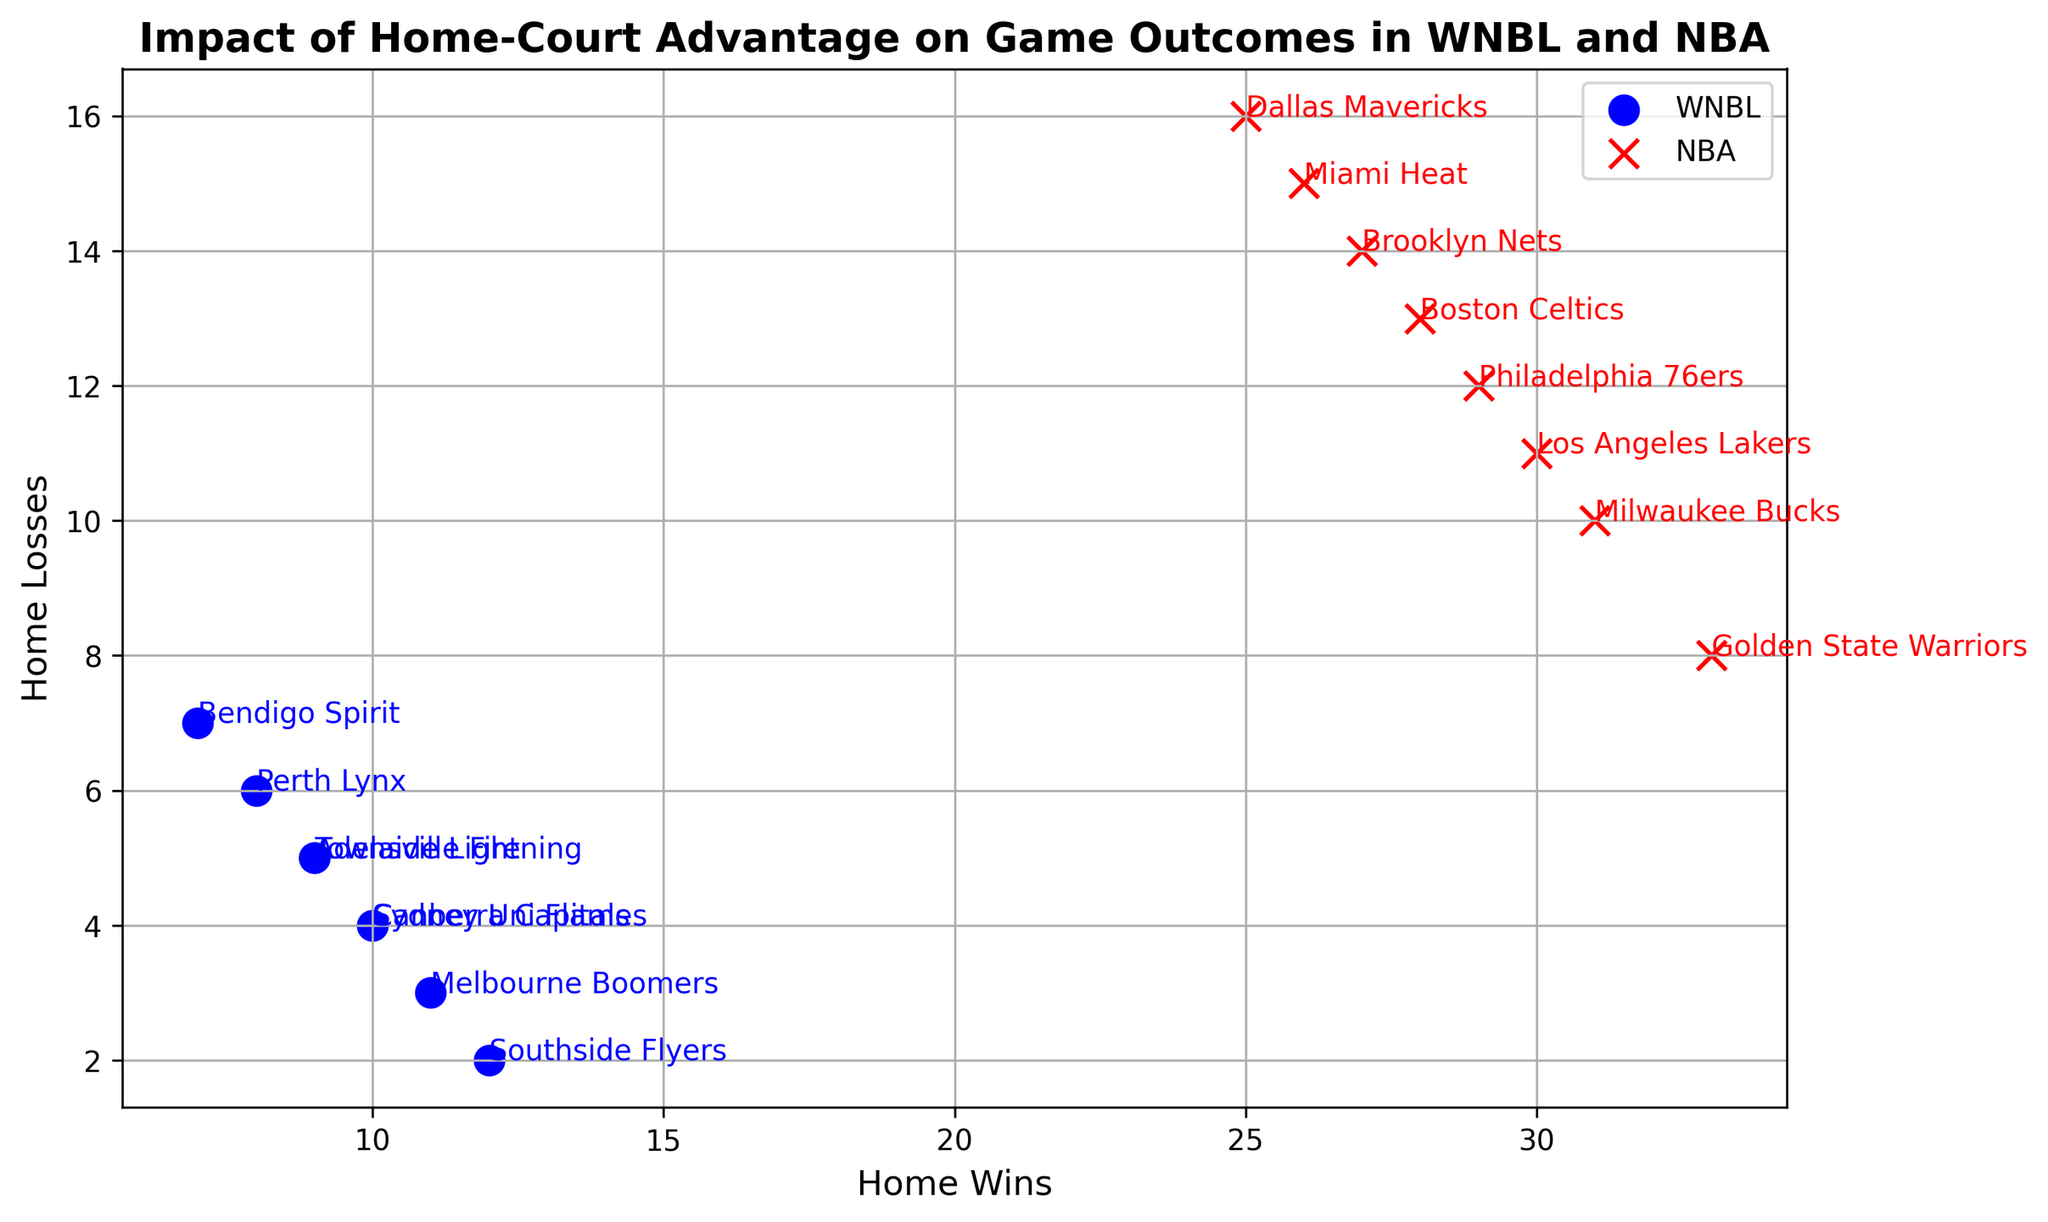Which team has the most home wins in the WNBL? The Southside Flyers have the most home wins in the WNBL with 12 wins, as indicated by the blue dot located farthest to the right.
Answer: Southside Flyers How many home losses do the Perth Lynx have and how does it compare to the Los Angeles Lakers? The Perth Lynx have 6 home losses, whereas the Los Angeles Lakers have 11 home losses. This comparison shows that the Los Angeles Lakers have more home losses than the Perth Lynx.
Answer: Perth Lynx have 6, Los Angeles Lakers have 11 Which NBA team has the least number of home losses and how many do they have? The Golden State Warriors have the least number of home losses among NBA teams with 8 losses, indicated by the red 'x' positioned lowest on the loss axis.
Answer: Golden State Warriors, 8 What is the difference between the home wins of the Melbourne Boomers and the Boston Celtics? The Melbourne Boomers have 11 home wins and the Boston Celtics have 28, so the difference is 28-11 = 17 wins.
Answer: 17 wins Who has more home wins, the Sydney Uni Flames or the Miami Heat, and by how many? The Sydney Uni Flames have 10 home wins, while the Miami Heat have 26 home wins. Therefore, the Miami Heat have 26 - 10 = 16 more home wins than the Sydney Uni Flames.
Answer: Miami Heat, by 16 What is the total number of home wins for all WNBL teams combined? Adding the home wins of all WNBL teams: 10 (Sydney Uni Flames) + 11 (Melbourne Boomers) + 9 (Adelaide Lightning) + 8 (Perth Lynx) + 12 (Southside Flyers) + 10 (Canberra Capitals) + 7 (Bendigo Spirit) + 9 (Townsville Fire) results in a total of 76 home wins.
Answer: 76 Which WNBL team has the closest number of home losses to the Brooklyn Nets? The Brooklyn Nets have 14 home losses. Among WNBL teams, Bendigo Spirit and Perth Lynx both have 7 home losses, which are half of Brooklyn Nets’ home losses.
Answer: Bendigo Spirit and Perth Lynx Are there any WNBL teams and NBA teams with an equal number of home wins? If so, which teams? No WNBL team has the exact same number of home wins as an NBA team. Each team's wins are unique.
Answer: None 